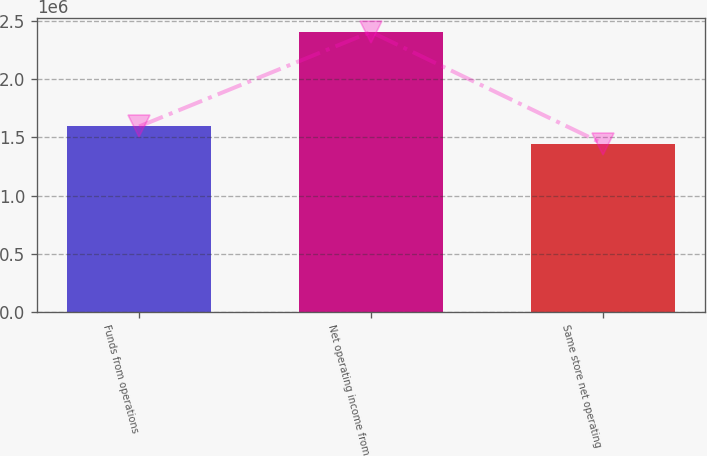Convert chart. <chart><loc_0><loc_0><loc_500><loc_500><bar_chart><fcel>Funds from operations<fcel>Net operating income from<fcel>Same store net operating<nl><fcel>1.59314e+06<fcel>2.40418e+06<fcel>1.44575e+06<nl></chart> 